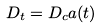Convert formula to latex. <formula><loc_0><loc_0><loc_500><loc_500>D _ { t } = D _ { c } a ( t )</formula> 